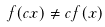<formula> <loc_0><loc_0><loc_500><loc_500>f ( c x ) \ne c f ( x )</formula> 